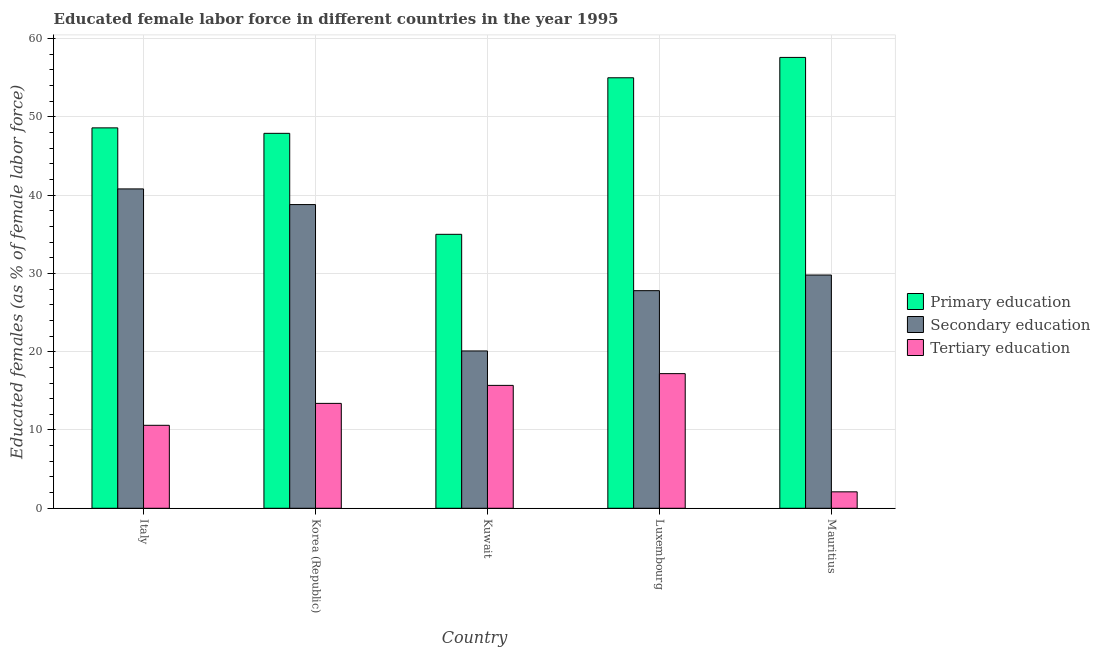How many different coloured bars are there?
Provide a short and direct response. 3. Are the number of bars on each tick of the X-axis equal?
Make the answer very short. Yes. What is the label of the 3rd group of bars from the left?
Ensure brevity in your answer.  Kuwait. What is the percentage of female labor force who received primary education in Kuwait?
Your answer should be very brief. 35. Across all countries, what is the maximum percentage of female labor force who received primary education?
Keep it short and to the point. 57.6. Across all countries, what is the minimum percentage of female labor force who received secondary education?
Offer a very short reply. 20.1. In which country was the percentage of female labor force who received primary education minimum?
Your answer should be compact. Kuwait. What is the total percentage of female labor force who received primary education in the graph?
Your answer should be compact. 244.1. What is the difference between the percentage of female labor force who received primary education in Korea (Republic) and that in Kuwait?
Offer a terse response. 12.9. What is the difference between the percentage of female labor force who received secondary education in Italy and the percentage of female labor force who received tertiary education in Mauritius?
Your response must be concise. 38.7. What is the average percentage of female labor force who received secondary education per country?
Your answer should be very brief. 31.46. What is the difference between the percentage of female labor force who received secondary education and percentage of female labor force who received tertiary education in Italy?
Provide a short and direct response. 30.2. What is the ratio of the percentage of female labor force who received primary education in Korea (Republic) to that in Luxembourg?
Your response must be concise. 0.87. What is the difference between the highest and the second highest percentage of female labor force who received primary education?
Your answer should be compact. 2.6. What is the difference between the highest and the lowest percentage of female labor force who received primary education?
Give a very brief answer. 22.6. In how many countries, is the percentage of female labor force who received primary education greater than the average percentage of female labor force who received primary education taken over all countries?
Ensure brevity in your answer.  2. What does the 2nd bar from the left in Korea (Republic) represents?
Your answer should be compact. Secondary education. What is the difference between two consecutive major ticks on the Y-axis?
Give a very brief answer. 10. Does the graph contain any zero values?
Make the answer very short. No. Does the graph contain grids?
Provide a succinct answer. Yes. How many legend labels are there?
Ensure brevity in your answer.  3. How are the legend labels stacked?
Ensure brevity in your answer.  Vertical. What is the title of the graph?
Offer a very short reply. Educated female labor force in different countries in the year 1995. What is the label or title of the X-axis?
Your response must be concise. Country. What is the label or title of the Y-axis?
Offer a very short reply. Educated females (as % of female labor force). What is the Educated females (as % of female labor force) of Primary education in Italy?
Provide a succinct answer. 48.6. What is the Educated females (as % of female labor force) in Secondary education in Italy?
Give a very brief answer. 40.8. What is the Educated females (as % of female labor force) in Tertiary education in Italy?
Keep it short and to the point. 10.6. What is the Educated females (as % of female labor force) of Primary education in Korea (Republic)?
Provide a short and direct response. 47.9. What is the Educated females (as % of female labor force) in Secondary education in Korea (Republic)?
Provide a short and direct response. 38.8. What is the Educated females (as % of female labor force) of Tertiary education in Korea (Republic)?
Provide a succinct answer. 13.4. What is the Educated females (as % of female labor force) in Secondary education in Kuwait?
Offer a very short reply. 20.1. What is the Educated females (as % of female labor force) of Tertiary education in Kuwait?
Your response must be concise. 15.7. What is the Educated females (as % of female labor force) of Secondary education in Luxembourg?
Make the answer very short. 27.8. What is the Educated females (as % of female labor force) of Tertiary education in Luxembourg?
Your response must be concise. 17.2. What is the Educated females (as % of female labor force) in Primary education in Mauritius?
Make the answer very short. 57.6. What is the Educated females (as % of female labor force) of Secondary education in Mauritius?
Offer a very short reply. 29.8. What is the Educated females (as % of female labor force) in Tertiary education in Mauritius?
Keep it short and to the point. 2.1. Across all countries, what is the maximum Educated females (as % of female labor force) of Primary education?
Your answer should be very brief. 57.6. Across all countries, what is the maximum Educated females (as % of female labor force) of Secondary education?
Keep it short and to the point. 40.8. Across all countries, what is the maximum Educated females (as % of female labor force) of Tertiary education?
Your answer should be compact. 17.2. Across all countries, what is the minimum Educated females (as % of female labor force) in Secondary education?
Offer a very short reply. 20.1. Across all countries, what is the minimum Educated females (as % of female labor force) in Tertiary education?
Your answer should be very brief. 2.1. What is the total Educated females (as % of female labor force) in Primary education in the graph?
Offer a very short reply. 244.1. What is the total Educated females (as % of female labor force) in Secondary education in the graph?
Keep it short and to the point. 157.3. What is the total Educated females (as % of female labor force) in Tertiary education in the graph?
Give a very brief answer. 59. What is the difference between the Educated females (as % of female labor force) in Secondary education in Italy and that in Korea (Republic)?
Your answer should be very brief. 2. What is the difference between the Educated females (as % of female labor force) in Secondary education in Italy and that in Kuwait?
Your answer should be very brief. 20.7. What is the difference between the Educated females (as % of female labor force) of Secondary education in Italy and that in Luxembourg?
Your response must be concise. 13. What is the difference between the Educated females (as % of female labor force) of Tertiary education in Italy and that in Luxembourg?
Provide a short and direct response. -6.6. What is the difference between the Educated females (as % of female labor force) in Secondary education in Italy and that in Mauritius?
Provide a short and direct response. 11. What is the difference between the Educated females (as % of female labor force) in Tertiary education in Italy and that in Mauritius?
Your answer should be compact. 8.5. What is the difference between the Educated females (as % of female labor force) of Primary education in Korea (Republic) and that in Kuwait?
Keep it short and to the point. 12.9. What is the difference between the Educated females (as % of female labor force) of Primary education in Korea (Republic) and that in Luxembourg?
Ensure brevity in your answer.  -7.1. What is the difference between the Educated females (as % of female labor force) of Secondary education in Korea (Republic) and that in Luxembourg?
Provide a succinct answer. 11. What is the difference between the Educated females (as % of female labor force) of Tertiary education in Korea (Republic) and that in Luxembourg?
Provide a short and direct response. -3.8. What is the difference between the Educated females (as % of female labor force) of Primary education in Korea (Republic) and that in Mauritius?
Make the answer very short. -9.7. What is the difference between the Educated females (as % of female labor force) in Tertiary education in Kuwait and that in Luxembourg?
Your answer should be compact. -1.5. What is the difference between the Educated females (as % of female labor force) of Primary education in Kuwait and that in Mauritius?
Give a very brief answer. -22.6. What is the difference between the Educated females (as % of female labor force) of Tertiary education in Kuwait and that in Mauritius?
Your answer should be compact. 13.6. What is the difference between the Educated females (as % of female labor force) of Secondary education in Luxembourg and that in Mauritius?
Make the answer very short. -2. What is the difference between the Educated females (as % of female labor force) of Tertiary education in Luxembourg and that in Mauritius?
Ensure brevity in your answer.  15.1. What is the difference between the Educated females (as % of female labor force) in Primary education in Italy and the Educated females (as % of female labor force) in Secondary education in Korea (Republic)?
Make the answer very short. 9.8. What is the difference between the Educated females (as % of female labor force) of Primary education in Italy and the Educated females (as % of female labor force) of Tertiary education in Korea (Republic)?
Your answer should be compact. 35.2. What is the difference between the Educated females (as % of female labor force) of Secondary education in Italy and the Educated females (as % of female labor force) of Tertiary education in Korea (Republic)?
Keep it short and to the point. 27.4. What is the difference between the Educated females (as % of female labor force) of Primary education in Italy and the Educated females (as % of female labor force) of Secondary education in Kuwait?
Your answer should be compact. 28.5. What is the difference between the Educated females (as % of female labor force) in Primary education in Italy and the Educated females (as % of female labor force) in Tertiary education in Kuwait?
Provide a short and direct response. 32.9. What is the difference between the Educated females (as % of female labor force) of Secondary education in Italy and the Educated females (as % of female labor force) of Tertiary education in Kuwait?
Keep it short and to the point. 25.1. What is the difference between the Educated females (as % of female labor force) of Primary education in Italy and the Educated females (as % of female labor force) of Secondary education in Luxembourg?
Your answer should be very brief. 20.8. What is the difference between the Educated females (as % of female labor force) in Primary education in Italy and the Educated females (as % of female labor force) in Tertiary education in Luxembourg?
Make the answer very short. 31.4. What is the difference between the Educated females (as % of female labor force) of Secondary education in Italy and the Educated females (as % of female labor force) of Tertiary education in Luxembourg?
Make the answer very short. 23.6. What is the difference between the Educated females (as % of female labor force) of Primary education in Italy and the Educated females (as % of female labor force) of Secondary education in Mauritius?
Ensure brevity in your answer.  18.8. What is the difference between the Educated females (as % of female labor force) of Primary education in Italy and the Educated females (as % of female labor force) of Tertiary education in Mauritius?
Ensure brevity in your answer.  46.5. What is the difference between the Educated females (as % of female labor force) in Secondary education in Italy and the Educated females (as % of female labor force) in Tertiary education in Mauritius?
Make the answer very short. 38.7. What is the difference between the Educated females (as % of female labor force) in Primary education in Korea (Republic) and the Educated females (as % of female labor force) in Secondary education in Kuwait?
Provide a succinct answer. 27.8. What is the difference between the Educated females (as % of female labor force) in Primary education in Korea (Republic) and the Educated females (as % of female labor force) in Tertiary education in Kuwait?
Keep it short and to the point. 32.2. What is the difference between the Educated females (as % of female labor force) of Secondary education in Korea (Republic) and the Educated females (as % of female labor force) of Tertiary education in Kuwait?
Your response must be concise. 23.1. What is the difference between the Educated females (as % of female labor force) of Primary education in Korea (Republic) and the Educated females (as % of female labor force) of Secondary education in Luxembourg?
Provide a short and direct response. 20.1. What is the difference between the Educated females (as % of female labor force) in Primary education in Korea (Republic) and the Educated females (as % of female labor force) in Tertiary education in Luxembourg?
Provide a succinct answer. 30.7. What is the difference between the Educated females (as % of female labor force) in Secondary education in Korea (Republic) and the Educated females (as % of female labor force) in Tertiary education in Luxembourg?
Make the answer very short. 21.6. What is the difference between the Educated females (as % of female labor force) of Primary education in Korea (Republic) and the Educated females (as % of female labor force) of Tertiary education in Mauritius?
Ensure brevity in your answer.  45.8. What is the difference between the Educated females (as % of female labor force) of Secondary education in Korea (Republic) and the Educated females (as % of female labor force) of Tertiary education in Mauritius?
Ensure brevity in your answer.  36.7. What is the difference between the Educated females (as % of female labor force) in Primary education in Kuwait and the Educated females (as % of female labor force) in Secondary education in Luxembourg?
Provide a succinct answer. 7.2. What is the difference between the Educated females (as % of female labor force) of Primary education in Kuwait and the Educated females (as % of female labor force) of Tertiary education in Mauritius?
Offer a very short reply. 32.9. What is the difference between the Educated females (as % of female labor force) of Secondary education in Kuwait and the Educated females (as % of female labor force) of Tertiary education in Mauritius?
Give a very brief answer. 18. What is the difference between the Educated females (as % of female labor force) of Primary education in Luxembourg and the Educated females (as % of female labor force) of Secondary education in Mauritius?
Make the answer very short. 25.2. What is the difference between the Educated females (as % of female labor force) in Primary education in Luxembourg and the Educated females (as % of female labor force) in Tertiary education in Mauritius?
Your answer should be very brief. 52.9. What is the difference between the Educated females (as % of female labor force) in Secondary education in Luxembourg and the Educated females (as % of female labor force) in Tertiary education in Mauritius?
Keep it short and to the point. 25.7. What is the average Educated females (as % of female labor force) in Primary education per country?
Ensure brevity in your answer.  48.82. What is the average Educated females (as % of female labor force) in Secondary education per country?
Offer a very short reply. 31.46. What is the average Educated females (as % of female labor force) in Tertiary education per country?
Provide a short and direct response. 11.8. What is the difference between the Educated females (as % of female labor force) of Primary education and Educated females (as % of female labor force) of Tertiary education in Italy?
Provide a short and direct response. 38. What is the difference between the Educated females (as % of female labor force) of Secondary education and Educated females (as % of female labor force) of Tertiary education in Italy?
Ensure brevity in your answer.  30.2. What is the difference between the Educated females (as % of female labor force) of Primary education and Educated females (as % of female labor force) of Secondary education in Korea (Republic)?
Offer a very short reply. 9.1. What is the difference between the Educated females (as % of female labor force) in Primary education and Educated females (as % of female labor force) in Tertiary education in Korea (Republic)?
Keep it short and to the point. 34.5. What is the difference between the Educated females (as % of female labor force) of Secondary education and Educated females (as % of female labor force) of Tertiary education in Korea (Republic)?
Offer a terse response. 25.4. What is the difference between the Educated females (as % of female labor force) in Primary education and Educated females (as % of female labor force) in Secondary education in Kuwait?
Offer a very short reply. 14.9. What is the difference between the Educated females (as % of female labor force) in Primary education and Educated females (as % of female labor force) in Tertiary education in Kuwait?
Provide a succinct answer. 19.3. What is the difference between the Educated females (as % of female labor force) of Secondary education and Educated females (as % of female labor force) of Tertiary education in Kuwait?
Ensure brevity in your answer.  4.4. What is the difference between the Educated females (as % of female labor force) in Primary education and Educated females (as % of female labor force) in Secondary education in Luxembourg?
Give a very brief answer. 27.2. What is the difference between the Educated females (as % of female labor force) in Primary education and Educated females (as % of female labor force) in Tertiary education in Luxembourg?
Offer a very short reply. 37.8. What is the difference between the Educated females (as % of female labor force) of Primary education and Educated females (as % of female labor force) of Secondary education in Mauritius?
Provide a short and direct response. 27.8. What is the difference between the Educated females (as % of female labor force) in Primary education and Educated females (as % of female labor force) in Tertiary education in Mauritius?
Provide a succinct answer. 55.5. What is the difference between the Educated females (as % of female labor force) in Secondary education and Educated females (as % of female labor force) in Tertiary education in Mauritius?
Your response must be concise. 27.7. What is the ratio of the Educated females (as % of female labor force) in Primary education in Italy to that in Korea (Republic)?
Your response must be concise. 1.01. What is the ratio of the Educated females (as % of female labor force) in Secondary education in Italy to that in Korea (Republic)?
Ensure brevity in your answer.  1.05. What is the ratio of the Educated females (as % of female labor force) of Tertiary education in Italy to that in Korea (Republic)?
Ensure brevity in your answer.  0.79. What is the ratio of the Educated females (as % of female labor force) in Primary education in Italy to that in Kuwait?
Your answer should be compact. 1.39. What is the ratio of the Educated females (as % of female labor force) of Secondary education in Italy to that in Kuwait?
Ensure brevity in your answer.  2.03. What is the ratio of the Educated females (as % of female labor force) of Tertiary education in Italy to that in Kuwait?
Provide a short and direct response. 0.68. What is the ratio of the Educated females (as % of female labor force) of Primary education in Italy to that in Luxembourg?
Your answer should be very brief. 0.88. What is the ratio of the Educated females (as % of female labor force) in Secondary education in Italy to that in Luxembourg?
Your answer should be compact. 1.47. What is the ratio of the Educated females (as % of female labor force) in Tertiary education in Italy to that in Luxembourg?
Give a very brief answer. 0.62. What is the ratio of the Educated females (as % of female labor force) in Primary education in Italy to that in Mauritius?
Your answer should be very brief. 0.84. What is the ratio of the Educated females (as % of female labor force) of Secondary education in Italy to that in Mauritius?
Ensure brevity in your answer.  1.37. What is the ratio of the Educated females (as % of female labor force) in Tertiary education in Italy to that in Mauritius?
Your response must be concise. 5.05. What is the ratio of the Educated females (as % of female labor force) of Primary education in Korea (Republic) to that in Kuwait?
Your answer should be very brief. 1.37. What is the ratio of the Educated females (as % of female labor force) in Secondary education in Korea (Republic) to that in Kuwait?
Offer a terse response. 1.93. What is the ratio of the Educated females (as % of female labor force) in Tertiary education in Korea (Republic) to that in Kuwait?
Provide a short and direct response. 0.85. What is the ratio of the Educated females (as % of female labor force) in Primary education in Korea (Republic) to that in Luxembourg?
Offer a very short reply. 0.87. What is the ratio of the Educated females (as % of female labor force) in Secondary education in Korea (Republic) to that in Luxembourg?
Provide a short and direct response. 1.4. What is the ratio of the Educated females (as % of female labor force) of Tertiary education in Korea (Republic) to that in Luxembourg?
Offer a terse response. 0.78. What is the ratio of the Educated females (as % of female labor force) in Primary education in Korea (Republic) to that in Mauritius?
Ensure brevity in your answer.  0.83. What is the ratio of the Educated females (as % of female labor force) of Secondary education in Korea (Republic) to that in Mauritius?
Ensure brevity in your answer.  1.3. What is the ratio of the Educated females (as % of female labor force) in Tertiary education in Korea (Republic) to that in Mauritius?
Offer a very short reply. 6.38. What is the ratio of the Educated females (as % of female labor force) of Primary education in Kuwait to that in Luxembourg?
Provide a succinct answer. 0.64. What is the ratio of the Educated females (as % of female labor force) in Secondary education in Kuwait to that in Luxembourg?
Make the answer very short. 0.72. What is the ratio of the Educated females (as % of female labor force) in Tertiary education in Kuwait to that in Luxembourg?
Offer a very short reply. 0.91. What is the ratio of the Educated females (as % of female labor force) in Primary education in Kuwait to that in Mauritius?
Provide a short and direct response. 0.61. What is the ratio of the Educated females (as % of female labor force) of Secondary education in Kuwait to that in Mauritius?
Your response must be concise. 0.67. What is the ratio of the Educated females (as % of female labor force) in Tertiary education in Kuwait to that in Mauritius?
Make the answer very short. 7.48. What is the ratio of the Educated females (as % of female labor force) in Primary education in Luxembourg to that in Mauritius?
Offer a very short reply. 0.95. What is the ratio of the Educated females (as % of female labor force) in Secondary education in Luxembourg to that in Mauritius?
Make the answer very short. 0.93. What is the ratio of the Educated females (as % of female labor force) of Tertiary education in Luxembourg to that in Mauritius?
Offer a very short reply. 8.19. What is the difference between the highest and the second highest Educated females (as % of female labor force) of Primary education?
Your response must be concise. 2.6. What is the difference between the highest and the lowest Educated females (as % of female labor force) of Primary education?
Ensure brevity in your answer.  22.6. What is the difference between the highest and the lowest Educated females (as % of female labor force) in Secondary education?
Provide a succinct answer. 20.7. What is the difference between the highest and the lowest Educated females (as % of female labor force) of Tertiary education?
Your response must be concise. 15.1. 